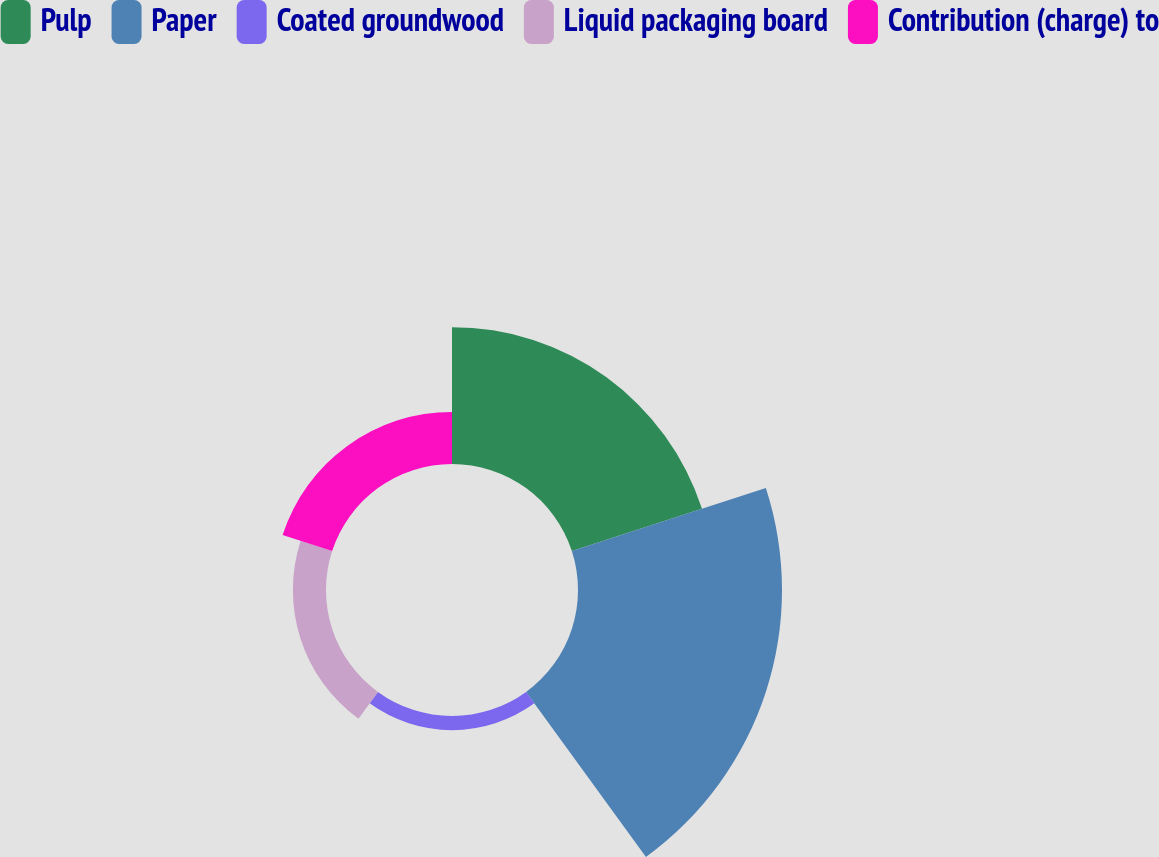Convert chart to OTSL. <chart><loc_0><loc_0><loc_500><loc_500><pie_chart><fcel>Pulp<fcel>Paper<fcel>Coated groundwood<fcel>Liquid packaging board<fcel>Contribution (charge) to<nl><fcel>31.09%<fcel>46.34%<fcel>3.21%<fcel>7.52%<fcel>11.84%<nl></chart> 